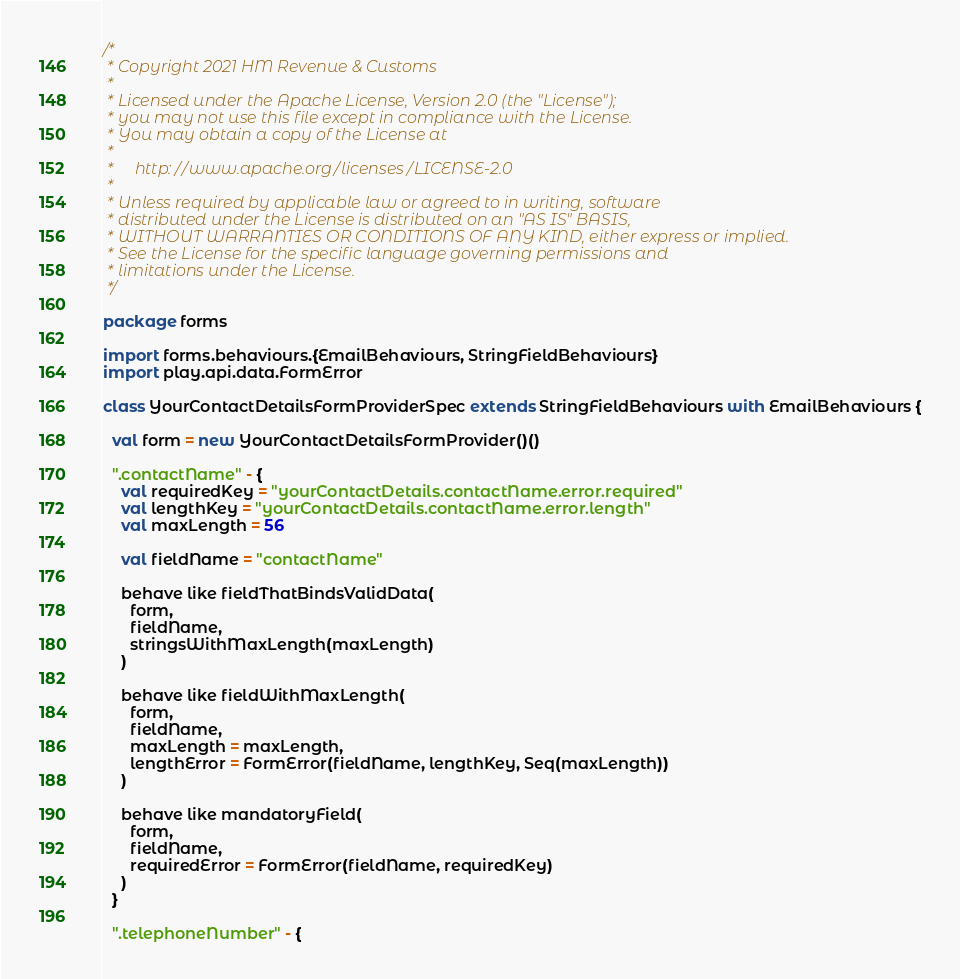Convert code to text. <code><loc_0><loc_0><loc_500><loc_500><_Scala_>/*
 * Copyright 2021 HM Revenue & Customs
 *
 * Licensed under the Apache License, Version 2.0 (the "License");
 * you may not use this file except in compliance with the License.
 * You may obtain a copy of the License at
 *
 *     http://www.apache.org/licenses/LICENSE-2.0
 *
 * Unless required by applicable law or agreed to in writing, software
 * distributed under the License is distributed on an "AS IS" BASIS,
 * WITHOUT WARRANTIES OR CONDITIONS OF ANY KIND, either express or implied.
 * See the License for the specific language governing permissions and
 * limitations under the License.
 */

package forms

import forms.behaviours.{EmailBehaviours, StringFieldBehaviours}
import play.api.data.FormError

class YourContactDetailsFormProviderSpec extends StringFieldBehaviours with EmailBehaviours {

  val form = new YourContactDetailsFormProvider()()

  ".contactName" - {
    val requiredKey = "yourContactDetails.contactName.error.required"
    val lengthKey = "yourContactDetails.contactName.error.length"
    val maxLength = 56

    val fieldName = "contactName"

    behave like fieldThatBindsValidData(
      form,
      fieldName,
      stringsWithMaxLength(maxLength)
    )

    behave like fieldWithMaxLength(
      form,
      fieldName,
      maxLength = maxLength,
      lengthError = FormError(fieldName, lengthKey, Seq(maxLength))
    )

    behave like mandatoryField(
      form,
      fieldName,
      requiredError = FormError(fieldName, requiredKey)
    )
  }

  ".telephoneNumber" - {</code> 